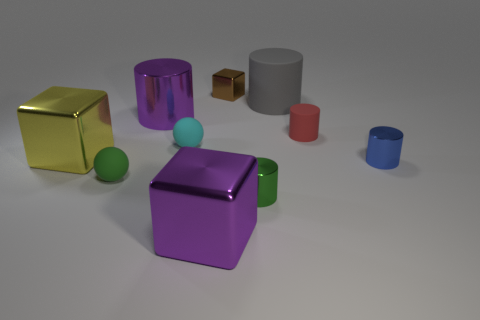What shape is the blue object?
Keep it short and to the point. Cylinder. There is a sphere that is left of the big cylinder in front of the gray object; are there any big purple cylinders in front of it?
Provide a succinct answer. No. What color is the shiny cylinder behind the shiny thing that is to the left of the purple metallic thing that is behind the red object?
Your response must be concise. Purple. There is a cyan object that is the same shape as the green matte object; what is it made of?
Make the answer very short. Rubber. What size is the ball behind the large block that is behind the small blue cylinder?
Your answer should be compact. Small. What is the material of the tiny thing that is behind the tiny matte cylinder?
Keep it short and to the point. Metal. There is a yellow cube that is the same material as the purple cylinder; what is its size?
Ensure brevity in your answer.  Large. How many tiny blue metallic objects have the same shape as the gray matte object?
Your response must be concise. 1. There is a small brown metallic object; is it the same shape as the large thing that is in front of the tiny green matte object?
Provide a short and direct response. Yes. Is there a tiny cube that has the same material as the cyan thing?
Keep it short and to the point. No. 